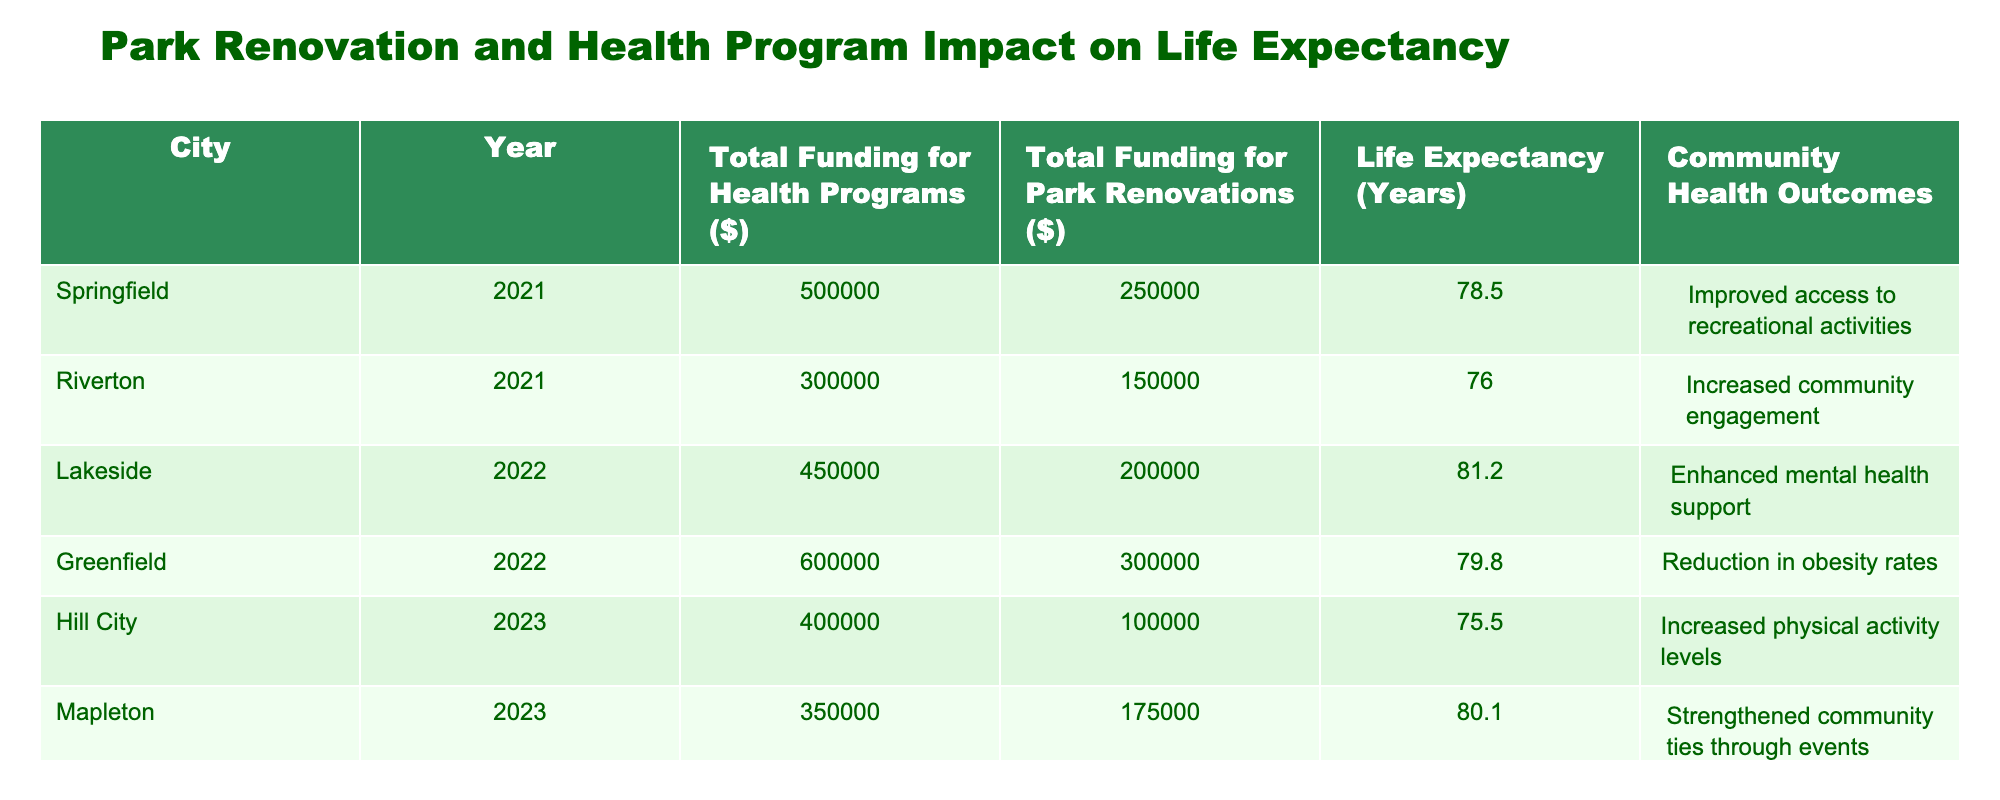What is the life expectancy in Springfield for the year 2021? According to the table, Springfield's life expectancy in 2021 is listed as 78.5 years.
Answer: 78.5 years Which city had the highest total funding for health programs? By checking the "Total Funding for Health Programs ($)" column, Lakeside has the highest funding amount of 450,000 dollars in 2022.
Answer: Lakeside What is the average life expectancy of the cities listed in 2023? The life expectancies for 2023 are 75.5 years (Hill City) and 80.1 years (Mapleton). To find the average, we sum them: 75.5 + 80.1 = 155.6, and then divide by 2, which gives us 155.6 / 2 = 77.8 years.
Answer: 77.8 years Is the community health outcome for Greenfield a reduction in obesity rates? Yes, the table clearly states that Greenfield's community health outcome is "Reduction in obesity rates".
Answer: Yes What is the total funding for health programs across all cities in 2022? In 2022, Lakeside had 450,000 dollars and Greenfield had 600,000 dollars in total health program funding. Adding these amounts together gives: 450,000 + 600,000 = 1,050,000 dollars total funding for health programs in 2022.
Answer: 1,050,000 dollars Which city's investment in park renovations had the least amount of funding? From the "Total Funding for Park Renovations ($)" column, Hill City had the least amount of funding for park renovations at 100,000 dollars in 2023.
Answer: Hill City What is the difference in life expectancy between the city with the highest and the lowest in 2021? The life expectancy in Springfield in 2021 is 78.5 years, while the lowest life expectancy in Riverton is 76.0 years. The difference is 78.5 - 76.0 = 2.5 years.
Answer: 2.5 years In which year did the total funding for park renovations reach 300,000 dollars? The table shows that Greenfield had a total funding for park renovations of 300,000 dollars in 2022.
Answer: 2022 What was the community health outcome for Hill City in 2023? According to the table, Hill City's community health outcome is listed as "Increased physical activity levels".
Answer: Increased physical activity levels 